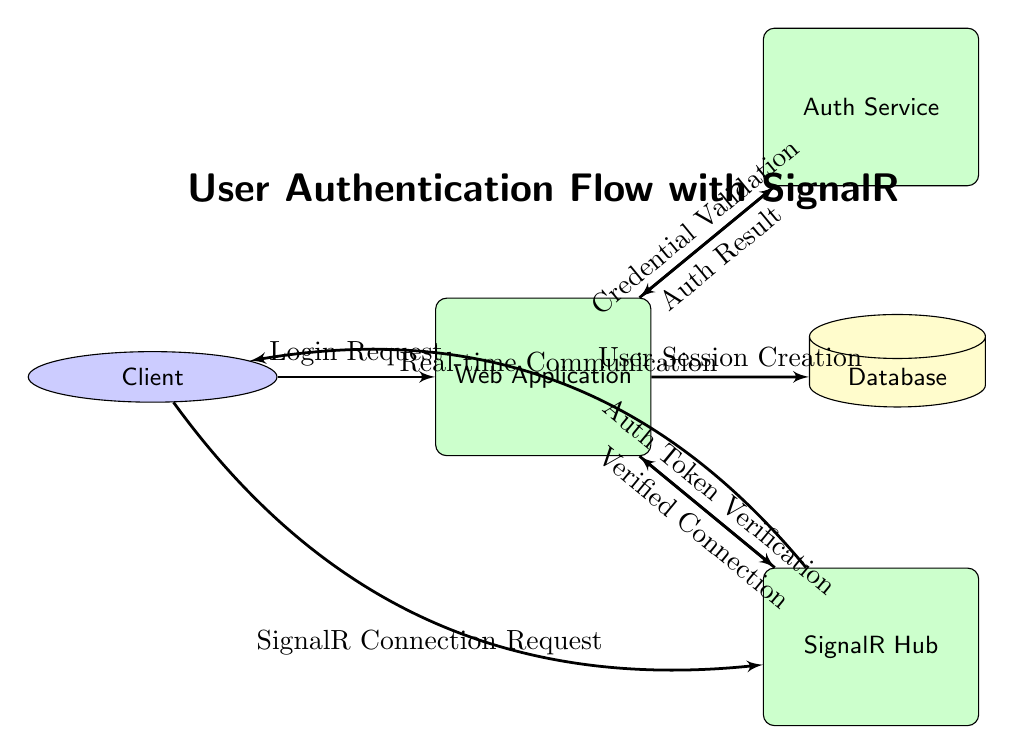What's the total number of nodes in the diagram? The diagram consists of six nodes: Client, Web Application, Auth Service, SignalR Hub, Database, and the flow lines connecting them. This includes process and data store nodes only.
Answer: 6 What is the purpose of the SignalR Hub in this flow? The SignalR Hub is responsible for managing real-time communication between the Client and the Web Application, facilitating the connection requests from the Client and verifying the authentication tokens.
Answer: Manage communication What flows from the Auth Service to the Web Application? The flow is labeled "Auth Result," indicating that the Auth Service returns the results of the user credential validation to the Web Application.
Answer: Auth Result Which process validates user credentials? The process that validates user credentials is labeled "Auth Service," as indicated by the flow connection going from the Web Application to this node.
Answer: Auth Service How many data flows originate from the Client? There are two data flows originating from the Client: "Login Request" to the Web Application and "SignalR Connection Request" to the SignalR Hub. Counting these flows gives the total.
Answer: 2 What is the relationship between the Web Application and the Database? The Web Application sends a "User Session Creation" flow to the Database, indicating that it creates or updates user session information in the Database.
Answer: User Session Creation What action does the SignalR Hub take after receiving a connection request? The SignalR Hub performs "Authentication Token Verification" to confirm the user's identity before establishing a verified connection with the Web Application.
Answer: Authentication Token Verification Which element is the actor in this flow? The actor in this flow is the "Client," which represents the user or application making the request to authenticate through the Web Application.
Answer: Client What kind of communication occurs after the verified connection is established? After the verified connection is established, "Real-time Communication" occurs between the SignalR Hub and the Client, allowing dynamic data exchange.
Answer: Real-time Communication 